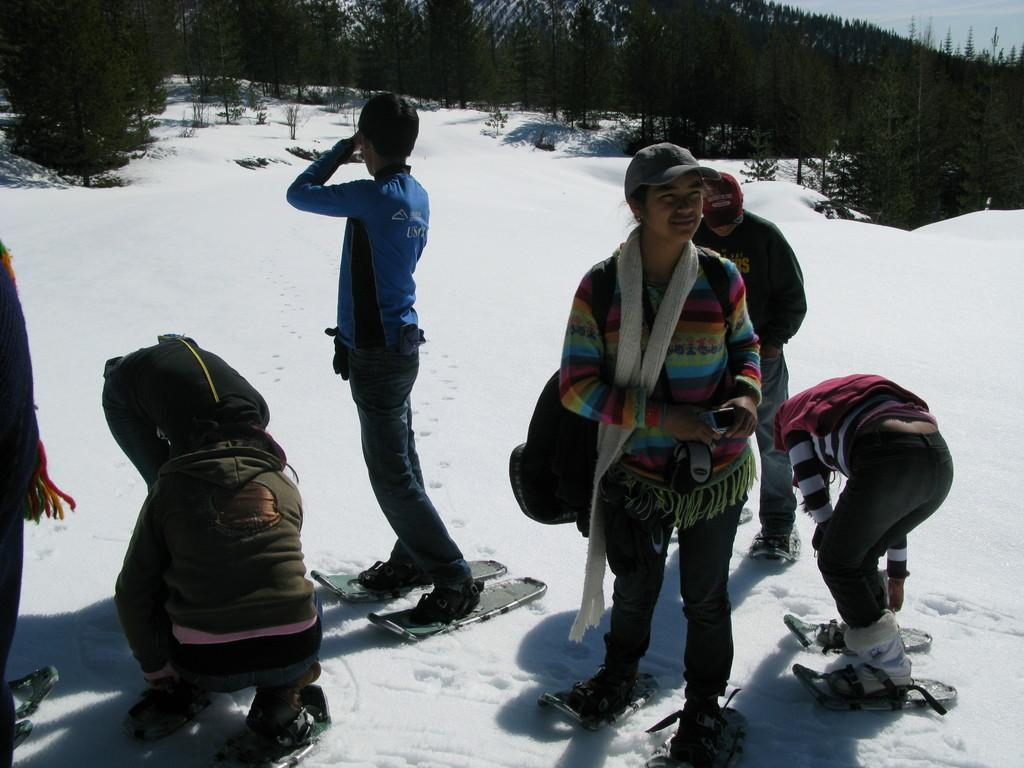Who is present in the image? There are people in the image. What activity are the people engaged in? The people are skating on the ice and using skateboards. What can be seen in the background of the image? There are trees and the sky visible in the background of the image. What thoughts are going through the boy's mind in the image? There is no boy present in the image, and therefore no thoughts can be attributed to a boy. 